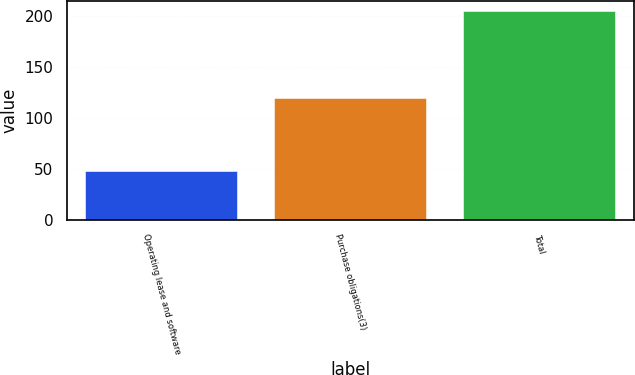<chart> <loc_0><loc_0><loc_500><loc_500><bar_chart><fcel>Operating lease and software<fcel>Purchase obligations(3)<fcel>Total<nl><fcel>47.7<fcel>119.1<fcel>204.2<nl></chart> 